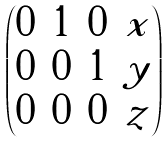<formula> <loc_0><loc_0><loc_500><loc_500>\begin{pmatrix} 0 & 1 & 0 & x \\ 0 & 0 & 1 & y \\ 0 & 0 & 0 & z \\ \end{pmatrix}</formula> 